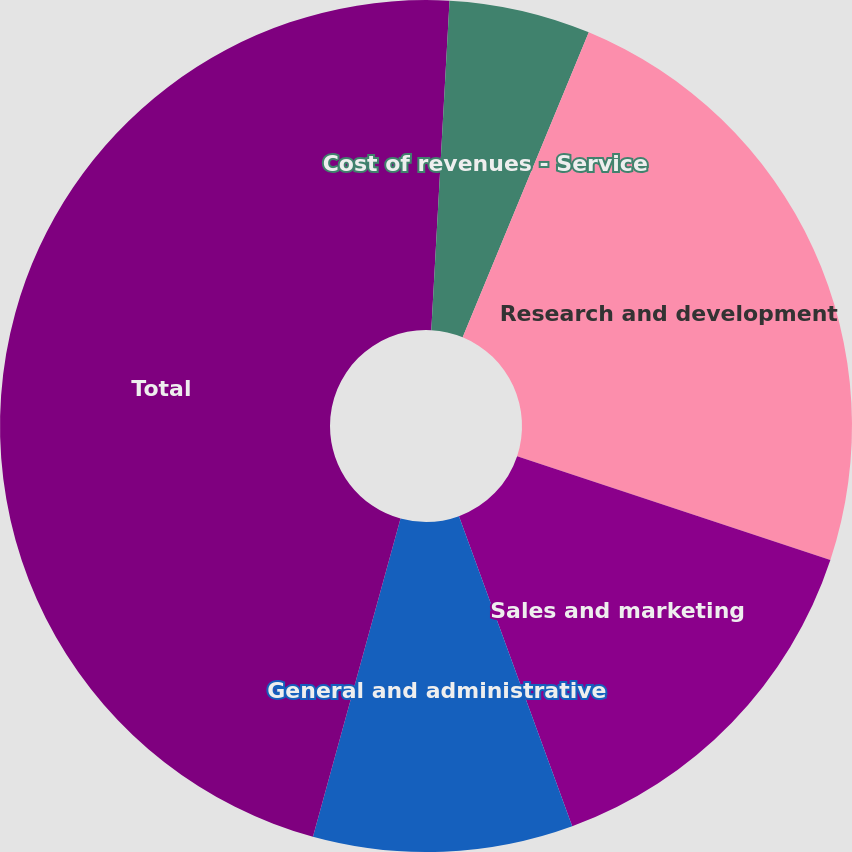<chart> <loc_0><loc_0><loc_500><loc_500><pie_chart><fcel>Cost of revenues - Product<fcel>Cost of revenues - Service<fcel>Research and development<fcel>Sales and marketing<fcel>General and administrative<fcel>Total<nl><fcel>0.88%<fcel>5.36%<fcel>23.85%<fcel>14.33%<fcel>9.85%<fcel>45.72%<nl></chart> 